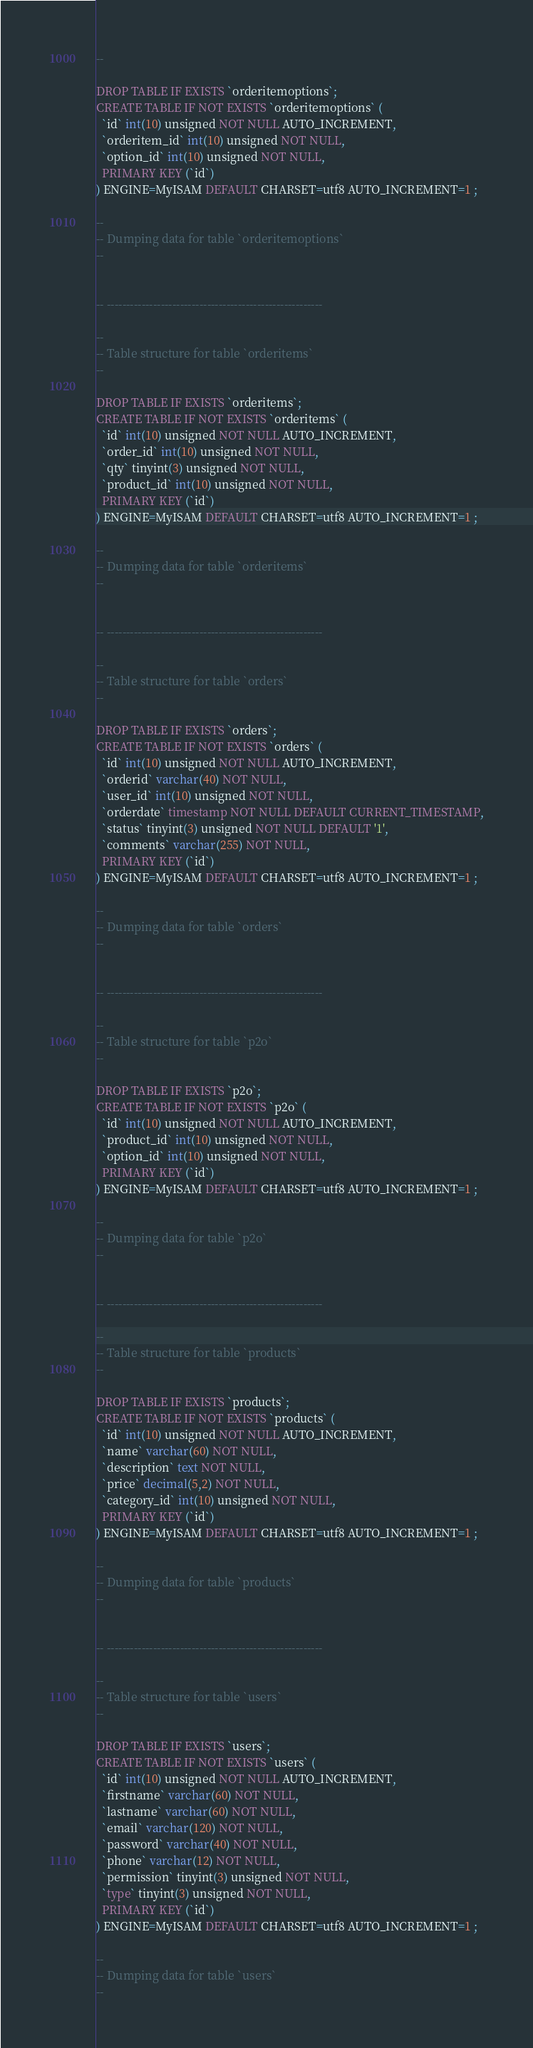Convert code to text. <code><loc_0><loc_0><loc_500><loc_500><_SQL_>--

DROP TABLE IF EXISTS `orderitemoptions`;
CREATE TABLE IF NOT EXISTS `orderitemoptions` (
  `id` int(10) unsigned NOT NULL AUTO_INCREMENT,
  `orderitem_id` int(10) unsigned NOT NULL,
  `option_id` int(10) unsigned NOT NULL,
  PRIMARY KEY (`id`)
) ENGINE=MyISAM DEFAULT CHARSET=utf8 AUTO_INCREMENT=1 ;

--
-- Dumping data for table `orderitemoptions`
--


-- --------------------------------------------------------

--
-- Table structure for table `orderitems`
--

DROP TABLE IF EXISTS `orderitems`;
CREATE TABLE IF NOT EXISTS `orderitems` (
  `id` int(10) unsigned NOT NULL AUTO_INCREMENT,
  `order_id` int(10) unsigned NOT NULL,
  `qty` tinyint(3) unsigned NOT NULL,
  `product_id` int(10) unsigned NOT NULL,
  PRIMARY KEY (`id`)
) ENGINE=MyISAM DEFAULT CHARSET=utf8 AUTO_INCREMENT=1 ;

--
-- Dumping data for table `orderitems`
--


-- --------------------------------------------------------

--
-- Table structure for table `orders`
--

DROP TABLE IF EXISTS `orders`;
CREATE TABLE IF NOT EXISTS `orders` (
  `id` int(10) unsigned NOT NULL AUTO_INCREMENT,
  `orderid` varchar(40) NOT NULL,
  `user_id` int(10) unsigned NOT NULL,
  `orderdate` timestamp NOT NULL DEFAULT CURRENT_TIMESTAMP,
  `status` tinyint(3) unsigned NOT NULL DEFAULT '1',
  `comments` varchar(255) NOT NULL,
  PRIMARY KEY (`id`)
) ENGINE=MyISAM DEFAULT CHARSET=utf8 AUTO_INCREMENT=1 ;

--
-- Dumping data for table `orders`
--


-- --------------------------------------------------------

--
-- Table structure for table `p2o`
--

DROP TABLE IF EXISTS `p2o`;
CREATE TABLE IF NOT EXISTS `p2o` (
  `id` int(10) unsigned NOT NULL AUTO_INCREMENT,
  `product_id` int(10) unsigned NOT NULL,
  `option_id` int(10) unsigned NOT NULL,
  PRIMARY KEY (`id`)
) ENGINE=MyISAM DEFAULT CHARSET=utf8 AUTO_INCREMENT=1 ;

--
-- Dumping data for table `p2o`
--


-- --------------------------------------------------------

--
-- Table structure for table `products`
--

DROP TABLE IF EXISTS `products`;
CREATE TABLE IF NOT EXISTS `products` (
  `id` int(10) unsigned NOT NULL AUTO_INCREMENT,
  `name` varchar(60) NOT NULL,
  `description` text NOT NULL,
  `price` decimal(5,2) NOT NULL,
  `category_id` int(10) unsigned NOT NULL,
  PRIMARY KEY (`id`)
) ENGINE=MyISAM DEFAULT CHARSET=utf8 AUTO_INCREMENT=1 ;

--
-- Dumping data for table `products`
--


-- --------------------------------------------------------

--
-- Table structure for table `users`
--

DROP TABLE IF EXISTS `users`;
CREATE TABLE IF NOT EXISTS `users` (
  `id` int(10) unsigned NOT NULL AUTO_INCREMENT,
  `firstname` varchar(60) NOT NULL,
  `lastname` varchar(60) NOT NULL,
  `email` varchar(120) NOT NULL,
  `password` varchar(40) NOT NULL,
  `phone` varchar(12) NOT NULL,
  `permission` tinyint(3) unsigned NOT NULL,
  `type` tinyint(3) unsigned NOT NULL,
  PRIMARY KEY (`id`)
) ENGINE=MyISAM DEFAULT CHARSET=utf8 AUTO_INCREMENT=1 ;

--
-- Dumping data for table `users`
--

</code> 